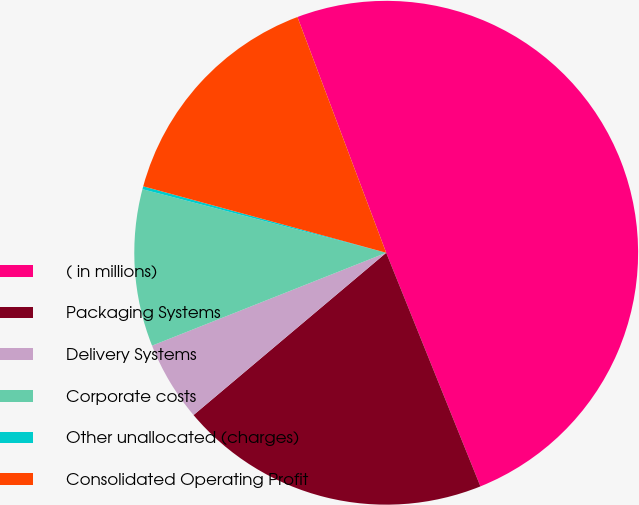Convert chart. <chart><loc_0><loc_0><loc_500><loc_500><pie_chart><fcel>( in millions)<fcel>Packaging Systems<fcel>Delivery Systems<fcel>Corporate costs<fcel>Other unallocated (charges)<fcel>Consolidated Operating Profit<nl><fcel>49.63%<fcel>19.96%<fcel>5.13%<fcel>10.07%<fcel>0.19%<fcel>15.02%<nl></chart> 